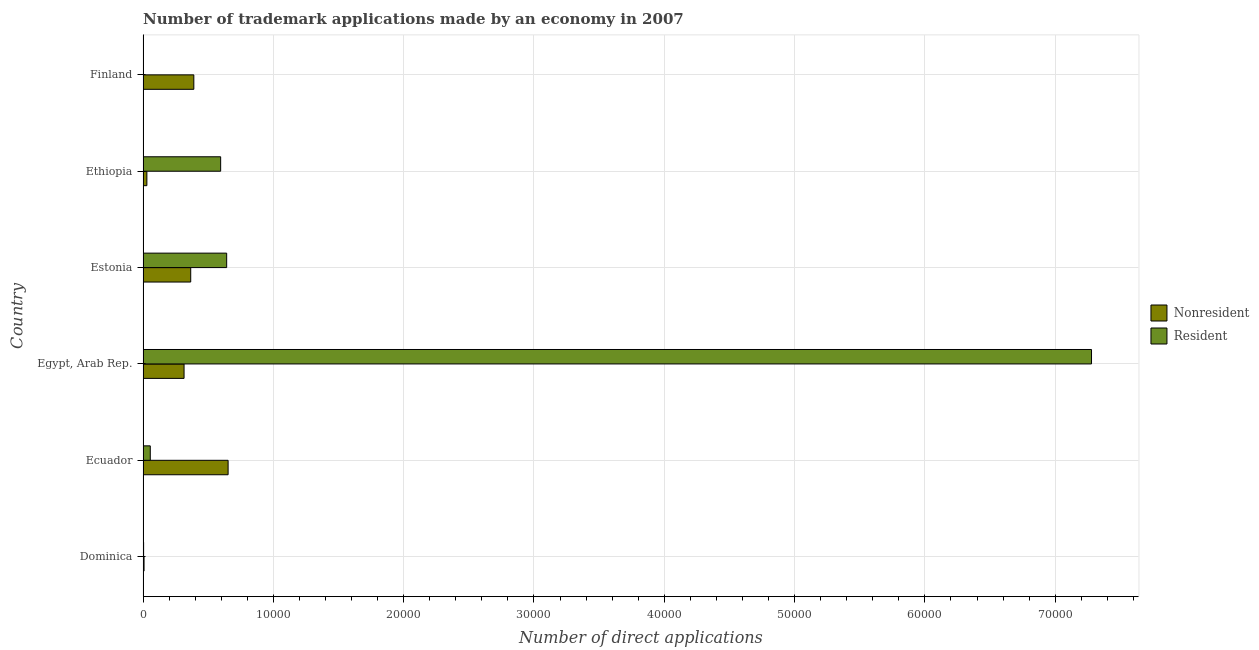How many different coloured bars are there?
Provide a succinct answer. 2. How many bars are there on the 5th tick from the top?
Give a very brief answer. 2. How many bars are there on the 4th tick from the bottom?
Provide a short and direct response. 2. What is the label of the 6th group of bars from the top?
Offer a very short reply. Dominica. What is the number of trademark applications made by non residents in Estonia?
Provide a succinct answer. 3657. Across all countries, what is the maximum number of trademark applications made by residents?
Ensure brevity in your answer.  7.28e+04. Across all countries, what is the minimum number of trademark applications made by non residents?
Make the answer very short. 76. In which country was the number of trademark applications made by residents maximum?
Offer a terse response. Egypt, Arab Rep. In which country was the number of trademark applications made by non residents minimum?
Ensure brevity in your answer.  Dominica. What is the total number of trademark applications made by non residents in the graph?
Make the answer very short. 1.76e+04. What is the difference between the number of trademark applications made by non residents in Estonia and that in Finland?
Ensure brevity in your answer.  -239. What is the difference between the number of trademark applications made by non residents in Ecuador and the number of trademark applications made by residents in Ethiopia?
Give a very brief answer. 572. What is the average number of trademark applications made by non residents per country?
Provide a succinct answer. 2932.5. What is the difference between the number of trademark applications made by residents and number of trademark applications made by non residents in Finland?
Give a very brief answer. -3890. What is the ratio of the number of trademark applications made by non residents in Dominica to that in Estonia?
Your answer should be very brief. 0.02. Is the number of trademark applications made by residents in Egypt, Arab Rep. less than that in Estonia?
Make the answer very short. No. Is the difference between the number of trademark applications made by non residents in Estonia and Ethiopia greater than the difference between the number of trademark applications made by residents in Estonia and Ethiopia?
Keep it short and to the point. Yes. What is the difference between the highest and the second highest number of trademark applications made by residents?
Your response must be concise. 6.64e+04. What is the difference between the highest and the lowest number of trademark applications made by non residents?
Offer a terse response. 6451. What does the 1st bar from the top in Ethiopia represents?
Your answer should be compact. Resident. What does the 2nd bar from the bottom in Ecuador represents?
Give a very brief answer. Resident. What is the difference between two consecutive major ticks on the X-axis?
Give a very brief answer. 10000. Does the graph contain any zero values?
Provide a short and direct response. No. Does the graph contain grids?
Make the answer very short. Yes. How many legend labels are there?
Offer a terse response. 2. How are the legend labels stacked?
Make the answer very short. Vertical. What is the title of the graph?
Offer a very short reply. Number of trademark applications made by an economy in 2007. Does "IMF concessional" appear as one of the legend labels in the graph?
Offer a very short reply. No. What is the label or title of the X-axis?
Keep it short and to the point. Number of direct applications. What is the Number of direct applications in Nonresident in Dominica?
Your answer should be very brief. 76. What is the Number of direct applications in Nonresident in Ecuador?
Make the answer very short. 6527. What is the Number of direct applications of Resident in Ecuador?
Offer a very short reply. 554. What is the Number of direct applications in Nonresident in Egypt, Arab Rep.?
Keep it short and to the point. 3146. What is the Number of direct applications of Resident in Egypt, Arab Rep.?
Make the answer very short. 7.28e+04. What is the Number of direct applications of Nonresident in Estonia?
Your answer should be compact. 3657. What is the Number of direct applications in Resident in Estonia?
Your response must be concise. 6416. What is the Number of direct applications of Nonresident in Ethiopia?
Your response must be concise. 293. What is the Number of direct applications in Resident in Ethiopia?
Offer a very short reply. 5955. What is the Number of direct applications in Nonresident in Finland?
Your answer should be very brief. 3896. Across all countries, what is the maximum Number of direct applications of Nonresident?
Your response must be concise. 6527. Across all countries, what is the maximum Number of direct applications of Resident?
Provide a short and direct response. 7.28e+04. Across all countries, what is the minimum Number of direct applications of Resident?
Ensure brevity in your answer.  6. What is the total Number of direct applications of Nonresident in the graph?
Your answer should be very brief. 1.76e+04. What is the total Number of direct applications of Resident in the graph?
Provide a short and direct response. 8.58e+04. What is the difference between the Number of direct applications of Nonresident in Dominica and that in Ecuador?
Your answer should be compact. -6451. What is the difference between the Number of direct applications in Resident in Dominica and that in Ecuador?
Ensure brevity in your answer.  -512. What is the difference between the Number of direct applications of Nonresident in Dominica and that in Egypt, Arab Rep.?
Your answer should be compact. -3070. What is the difference between the Number of direct applications of Resident in Dominica and that in Egypt, Arab Rep.?
Provide a succinct answer. -7.27e+04. What is the difference between the Number of direct applications of Nonresident in Dominica and that in Estonia?
Provide a short and direct response. -3581. What is the difference between the Number of direct applications of Resident in Dominica and that in Estonia?
Give a very brief answer. -6374. What is the difference between the Number of direct applications of Nonresident in Dominica and that in Ethiopia?
Offer a terse response. -217. What is the difference between the Number of direct applications of Resident in Dominica and that in Ethiopia?
Offer a terse response. -5913. What is the difference between the Number of direct applications in Nonresident in Dominica and that in Finland?
Make the answer very short. -3820. What is the difference between the Number of direct applications in Resident in Dominica and that in Finland?
Offer a very short reply. 36. What is the difference between the Number of direct applications in Nonresident in Ecuador and that in Egypt, Arab Rep.?
Provide a short and direct response. 3381. What is the difference between the Number of direct applications in Resident in Ecuador and that in Egypt, Arab Rep.?
Keep it short and to the point. -7.22e+04. What is the difference between the Number of direct applications in Nonresident in Ecuador and that in Estonia?
Ensure brevity in your answer.  2870. What is the difference between the Number of direct applications of Resident in Ecuador and that in Estonia?
Give a very brief answer. -5862. What is the difference between the Number of direct applications in Nonresident in Ecuador and that in Ethiopia?
Offer a very short reply. 6234. What is the difference between the Number of direct applications in Resident in Ecuador and that in Ethiopia?
Make the answer very short. -5401. What is the difference between the Number of direct applications of Nonresident in Ecuador and that in Finland?
Your response must be concise. 2631. What is the difference between the Number of direct applications in Resident in Ecuador and that in Finland?
Ensure brevity in your answer.  548. What is the difference between the Number of direct applications in Nonresident in Egypt, Arab Rep. and that in Estonia?
Your response must be concise. -511. What is the difference between the Number of direct applications in Resident in Egypt, Arab Rep. and that in Estonia?
Provide a succinct answer. 6.64e+04. What is the difference between the Number of direct applications of Nonresident in Egypt, Arab Rep. and that in Ethiopia?
Ensure brevity in your answer.  2853. What is the difference between the Number of direct applications of Resident in Egypt, Arab Rep. and that in Ethiopia?
Your answer should be compact. 6.68e+04. What is the difference between the Number of direct applications of Nonresident in Egypt, Arab Rep. and that in Finland?
Your answer should be very brief. -750. What is the difference between the Number of direct applications of Resident in Egypt, Arab Rep. and that in Finland?
Offer a terse response. 7.28e+04. What is the difference between the Number of direct applications of Nonresident in Estonia and that in Ethiopia?
Make the answer very short. 3364. What is the difference between the Number of direct applications of Resident in Estonia and that in Ethiopia?
Keep it short and to the point. 461. What is the difference between the Number of direct applications of Nonresident in Estonia and that in Finland?
Your response must be concise. -239. What is the difference between the Number of direct applications in Resident in Estonia and that in Finland?
Make the answer very short. 6410. What is the difference between the Number of direct applications in Nonresident in Ethiopia and that in Finland?
Provide a succinct answer. -3603. What is the difference between the Number of direct applications of Resident in Ethiopia and that in Finland?
Provide a short and direct response. 5949. What is the difference between the Number of direct applications of Nonresident in Dominica and the Number of direct applications of Resident in Ecuador?
Give a very brief answer. -478. What is the difference between the Number of direct applications of Nonresident in Dominica and the Number of direct applications of Resident in Egypt, Arab Rep.?
Your answer should be very brief. -7.27e+04. What is the difference between the Number of direct applications of Nonresident in Dominica and the Number of direct applications of Resident in Estonia?
Keep it short and to the point. -6340. What is the difference between the Number of direct applications in Nonresident in Dominica and the Number of direct applications in Resident in Ethiopia?
Your answer should be compact. -5879. What is the difference between the Number of direct applications of Nonresident in Ecuador and the Number of direct applications of Resident in Egypt, Arab Rep.?
Offer a very short reply. -6.63e+04. What is the difference between the Number of direct applications in Nonresident in Ecuador and the Number of direct applications in Resident in Estonia?
Provide a short and direct response. 111. What is the difference between the Number of direct applications in Nonresident in Ecuador and the Number of direct applications in Resident in Ethiopia?
Your answer should be compact. 572. What is the difference between the Number of direct applications in Nonresident in Ecuador and the Number of direct applications in Resident in Finland?
Provide a succinct answer. 6521. What is the difference between the Number of direct applications in Nonresident in Egypt, Arab Rep. and the Number of direct applications in Resident in Estonia?
Make the answer very short. -3270. What is the difference between the Number of direct applications of Nonresident in Egypt, Arab Rep. and the Number of direct applications of Resident in Ethiopia?
Your answer should be compact. -2809. What is the difference between the Number of direct applications in Nonresident in Egypt, Arab Rep. and the Number of direct applications in Resident in Finland?
Keep it short and to the point. 3140. What is the difference between the Number of direct applications in Nonresident in Estonia and the Number of direct applications in Resident in Ethiopia?
Give a very brief answer. -2298. What is the difference between the Number of direct applications of Nonresident in Estonia and the Number of direct applications of Resident in Finland?
Provide a short and direct response. 3651. What is the difference between the Number of direct applications of Nonresident in Ethiopia and the Number of direct applications of Resident in Finland?
Ensure brevity in your answer.  287. What is the average Number of direct applications of Nonresident per country?
Your response must be concise. 2932.5. What is the average Number of direct applications of Resident per country?
Offer a very short reply. 1.43e+04. What is the difference between the Number of direct applications of Nonresident and Number of direct applications of Resident in Ecuador?
Your response must be concise. 5973. What is the difference between the Number of direct applications of Nonresident and Number of direct applications of Resident in Egypt, Arab Rep.?
Keep it short and to the point. -6.96e+04. What is the difference between the Number of direct applications of Nonresident and Number of direct applications of Resident in Estonia?
Ensure brevity in your answer.  -2759. What is the difference between the Number of direct applications in Nonresident and Number of direct applications in Resident in Ethiopia?
Provide a short and direct response. -5662. What is the difference between the Number of direct applications in Nonresident and Number of direct applications in Resident in Finland?
Make the answer very short. 3890. What is the ratio of the Number of direct applications in Nonresident in Dominica to that in Ecuador?
Offer a very short reply. 0.01. What is the ratio of the Number of direct applications in Resident in Dominica to that in Ecuador?
Make the answer very short. 0.08. What is the ratio of the Number of direct applications in Nonresident in Dominica to that in Egypt, Arab Rep.?
Offer a very short reply. 0.02. What is the ratio of the Number of direct applications in Resident in Dominica to that in Egypt, Arab Rep.?
Provide a short and direct response. 0. What is the ratio of the Number of direct applications of Nonresident in Dominica to that in Estonia?
Provide a succinct answer. 0.02. What is the ratio of the Number of direct applications in Resident in Dominica to that in Estonia?
Keep it short and to the point. 0.01. What is the ratio of the Number of direct applications of Nonresident in Dominica to that in Ethiopia?
Offer a terse response. 0.26. What is the ratio of the Number of direct applications of Resident in Dominica to that in Ethiopia?
Give a very brief answer. 0.01. What is the ratio of the Number of direct applications in Nonresident in Dominica to that in Finland?
Your response must be concise. 0.02. What is the ratio of the Number of direct applications in Resident in Dominica to that in Finland?
Your answer should be very brief. 7. What is the ratio of the Number of direct applications of Nonresident in Ecuador to that in Egypt, Arab Rep.?
Keep it short and to the point. 2.07. What is the ratio of the Number of direct applications of Resident in Ecuador to that in Egypt, Arab Rep.?
Offer a very short reply. 0.01. What is the ratio of the Number of direct applications in Nonresident in Ecuador to that in Estonia?
Your answer should be compact. 1.78. What is the ratio of the Number of direct applications of Resident in Ecuador to that in Estonia?
Offer a terse response. 0.09. What is the ratio of the Number of direct applications in Nonresident in Ecuador to that in Ethiopia?
Offer a very short reply. 22.28. What is the ratio of the Number of direct applications of Resident in Ecuador to that in Ethiopia?
Your response must be concise. 0.09. What is the ratio of the Number of direct applications in Nonresident in Ecuador to that in Finland?
Provide a short and direct response. 1.68. What is the ratio of the Number of direct applications in Resident in Ecuador to that in Finland?
Your answer should be compact. 92.33. What is the ratio of the Number of direct applications of Nonresident in Egypt, Arab Rep. to that in Estonia?
Ensure brevity in your answer.  0.86. What is the ratio of the Number of direct applications of Resident in Egypt, Arab Rep. to that in Estonia?
Provide a succinct answer. 11.34. What is the ratio of the Number of direct applications in Nonresident in Egypt, Arab Rep. to that in Ethiopia?
Ensure brevity in your answer.  10.74. What is the ratio of the Number of direct applications in Resident in Egypt, Arab Rep. to that in Ethiopia?
Your answer should be compact. 12.22. What is the ratio of the Number of direct applications in Nonresident in Egypt, Arab Rep. to that in Finland?
Ensure brevity in your answer.  0.81. What is the ratio of the Number of direct applications in Resident in Egypt, Arab Rep. to that in Finland?
Your answer should be very brief. 1.21e+04. What is the ratio of the Number of direct applications in Nonresident in Estonia to that in Ethiopia?
Give a very brief answer. 12.48. What is the ratio of the Number of direct applications of Resident in Estonia to that in Ethiopia?
Your answer should be very brief. 1.08. What is the ratio of the Number of direct applications of Nonresident in Estonia to that in Finland?
Offer a very short reply. 0.94. What is the ratio of the Number of direct applications in Resident in Estonia to that in Finland?
Ensure brevity in your answer.  1069.33. What is the ratio of the Number of direct applications in Nonresident in Ethiopia to that in Finland?
Make the answer very short. 0.08. What is the ratio of the Number of direct applications in Resident in Ethiopia to that in Finland?
Your answer should be compact. 992.5. What is the difference between the highest and the second highest Number of direct applications of Nonresident?
Give a very brief answer. 2631. What is the difference between the highest and the second highest Number of direct applications of Resident?
Provide a short and direct response. 6.64e+04. What is the difference between the highest and the lowest Number of direct applications of Nonresident?
Your answer should be compact. 6451. What is the difference between the highest and the lowest Number of direct applications of Resident?
Make the answer very short. 7.28e+04. 